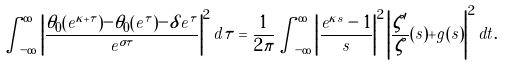<formula> <loc_0><loc_0><loc_500><loc_500>\int _ { - \infty } ^ { \infty } \left | \frac { \theta _ { 0 } ( e ^ { \kappa + \tau } ) - \theta _ { 0 } ( e ^ { \tau } ) - \delta e ^ { \tau } } { e ^ { \sigma \tau } } \right | ^ { 2 } d \tau = \frac { 1 } { 2 \pi } \int _ { - \infty } ^ { \infty } \left | \frac { e ^ { \kappa s } - 1 } { s } \right | ^ { 2 } \left | \frac { \zeta ^ { \prime } } { \zeta } ( s ) + g ( s ) \right | ^ { 2 } d t .</formula> 